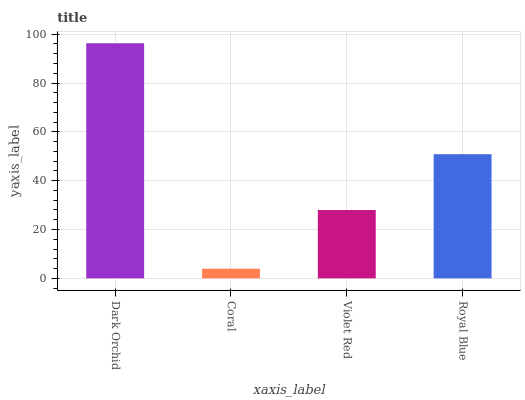Is Coral the minimum?
Answer yes or no. Yes. Is Dark Orchid the maximum?
Answer yes or no. Yes. Is Violet Red the minimum?
Answer yes or no. No. Is Violet Red the maximum?
Answer yes or no. No. Is Violet Red greater than Coral?
Answer yes or no. Yes. Is Coral less than Violet Red?
Answer yes or no. Yes. Is Coral greater than Violet Red?
Answer yes or no. No. Is Violet Red less than Coral?
Answer yes or no. No. Is Royal Blue the high median?
Answer yes or no. Yes. Is Violet Red the low median?
Answer yes or no. Yes. Is Dark Orchid the high median?
Answer yes or no. No. Is Coral the low median?
Answer yes or no. No. 